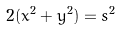<formula> <loc_0><loc_0><loc_500><loc_500>2 ( x ^ { 2 } + y ^ { 2 } ) = s ^ { 2 }</formula> 